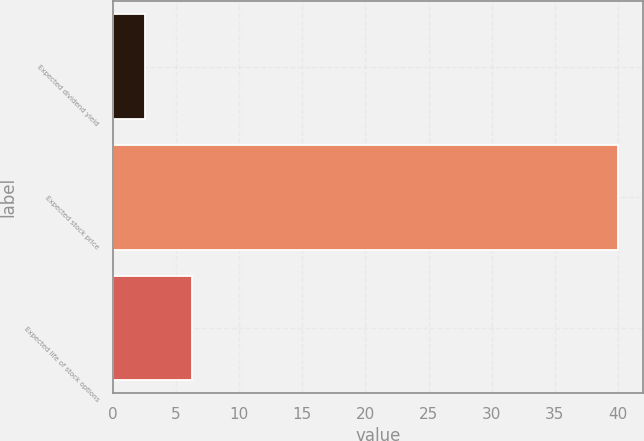Convert chart to OTSL. <chart><loc_0><loc_0><loc_500><loc_500><bar_chart><fcel>Expected dividend yield<fcel>Expected stock price<fcel>Expected life of stock options<nl><fcel>2.5<fcel>40<fcel>6.25<nl></chart> 